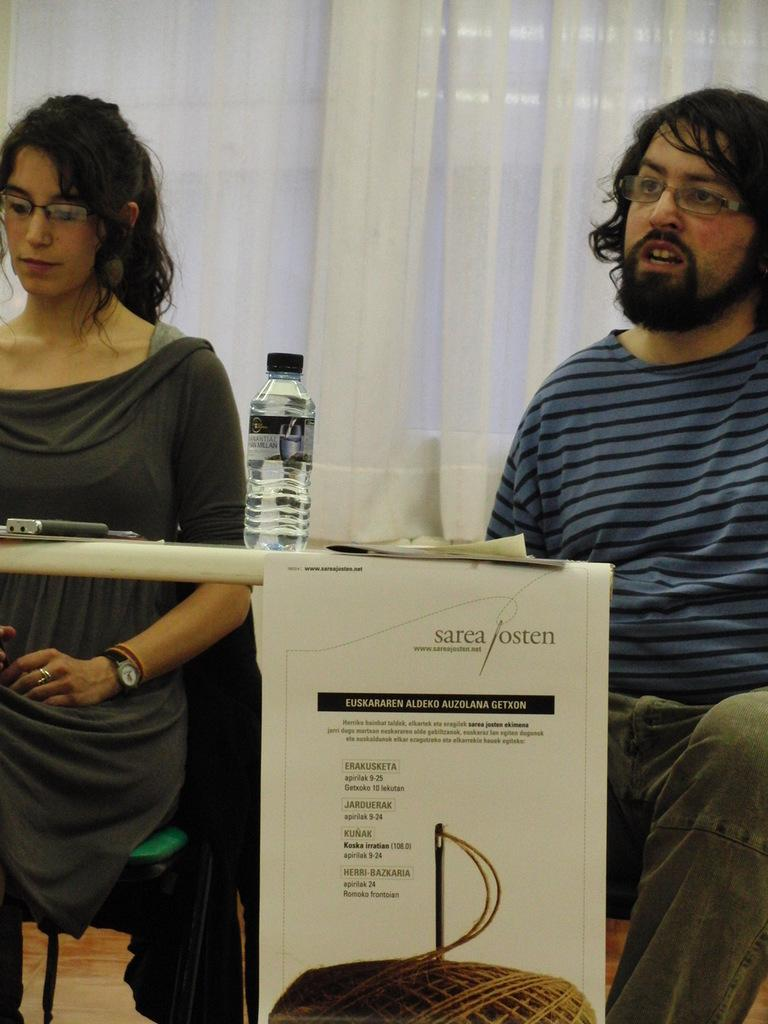How many people are in the image? There are two people in the image, a woman and a man. What are the woman and man doing in the image? Both the woman and man are sitting on chairs. What objects can be seen on the table in the image? There is a bottle, a phone, and a paper on the table. What additional item is present in the image? There is a banner in the image. What can be seen in the background of the image? There is a white curtain in the background of the image. What type of cable is being used by the cook in the image? There is no cook or cable present in the image. How does the woman change her outfit in the image? There is no indication of the woman changing her outfit in the image. 